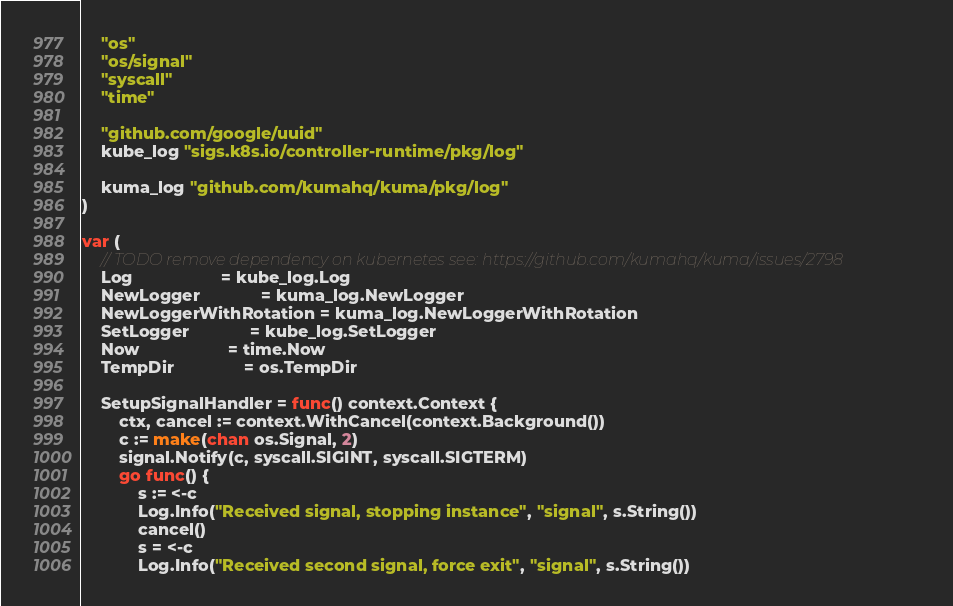<code> <loc_0><loc_0><loc_500><loc_500><_Go_>	"os"
	"os/signal"
	"syscall"
	"time"

	"github.com/google/uuid"
	kube_log "sigs.k8s.io/controller-runtime/pkg/log"

	kuma_log "github.com/kumahq/kuma/pkg/log"
)

var (
	// TODO remove dependency on kubernetes see: https://github.com/kumahq/kuma/issues/2798
	Log                   = kube_log.Log
	NewLogger             = kuma_log.NewLogger
	NewLoggerWithRotation = kuma_log.NewLoggerWithRotation
	SetLogger             = kube_log.SetLogger
	Now                   = time.Now
	TempDir               = os.TempDir

	SetupSignalHandler = func() context.Context {
		ctx, cancel := context.WithCancel(context.Background())
		c := make(chan os.Signal, 2)
		signal.Notify(c, syscall.SIGINT, syscall.SIGTERM)
		go func() {
			s := <-c
			Log.Info("Received signal, stopping instance", "signal", s.String())
			cancel()
			s = <-c
			Log.Info("Received second signal, force exit", "signal", s.String())</code> 